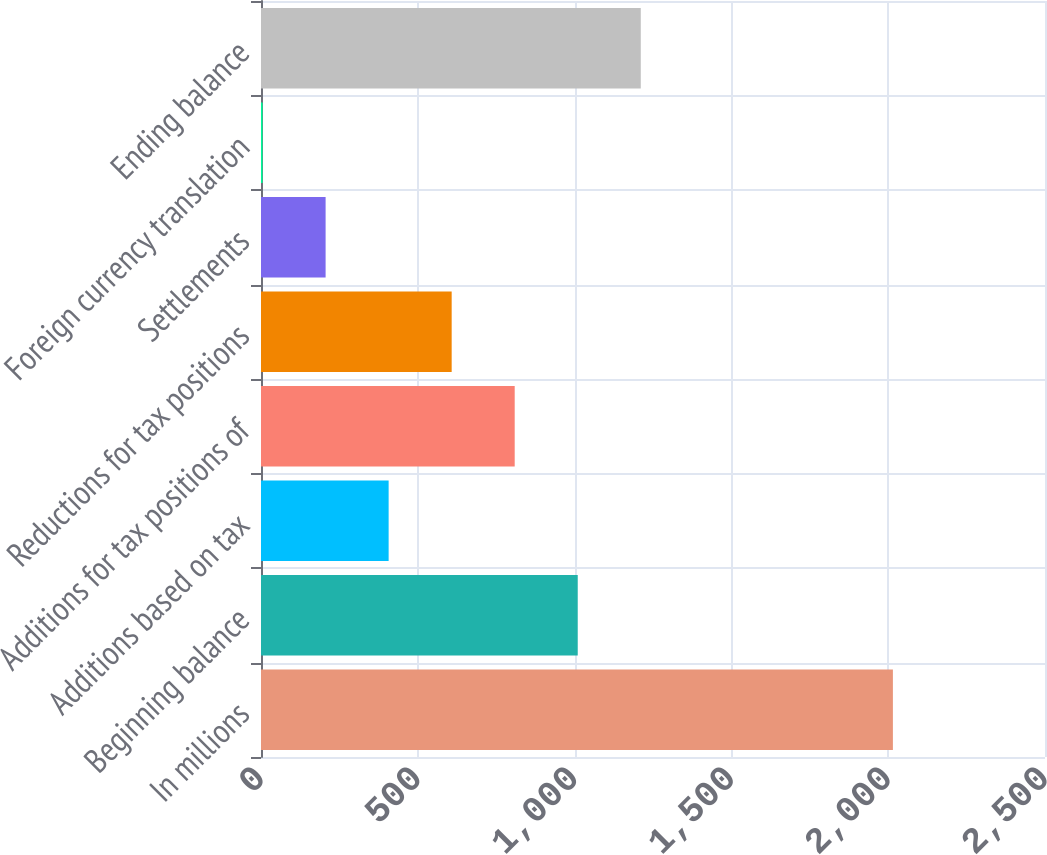Convert chart to OTSL. <chart><loc_0><loc_0><loc_500><loc_500><bar_chart><fcel>In millions<fcel>Beginning balance<fcel>Additions based on tax<fcel>Additions for tax positions of<fcel>Reductions for tax positions<fcel>Settlements<fcel>Foreign currency translation<fcel>Ending balance<nl><fcel>2015<fcel>1010<fcel>407<fcel>809<fcel>608<fcel>206<fcel>5<fcel>1211<nl></chart> 